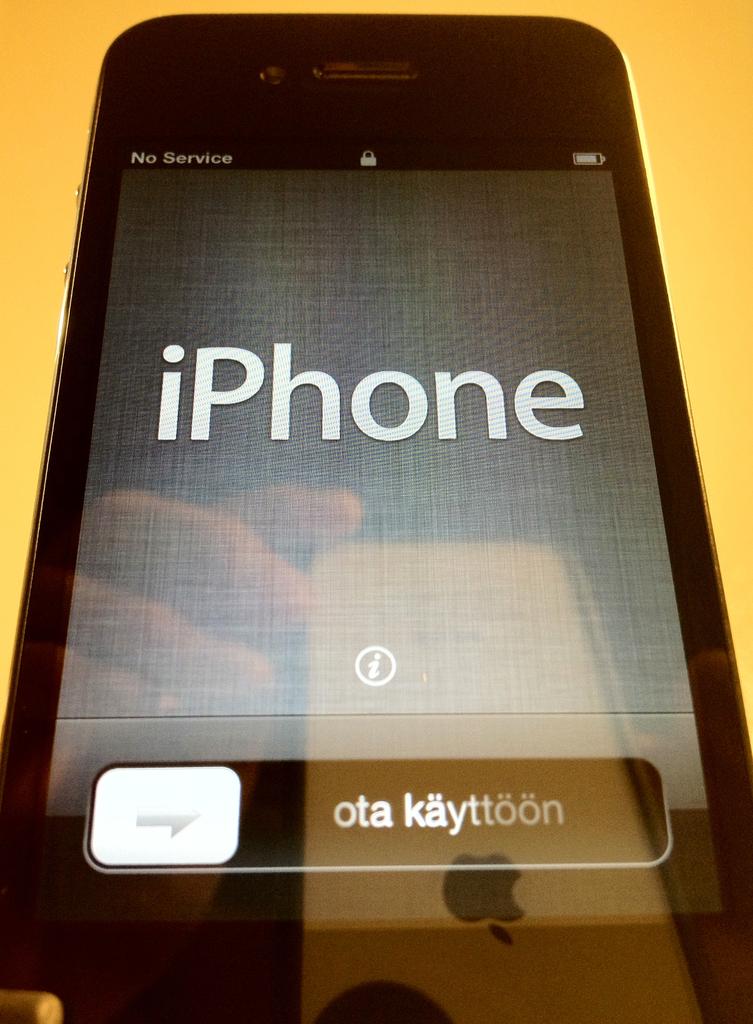Does this phone have service?
Give a very brief answer. No. What brand of phone is this?
Make the answer very short. Iphone. 